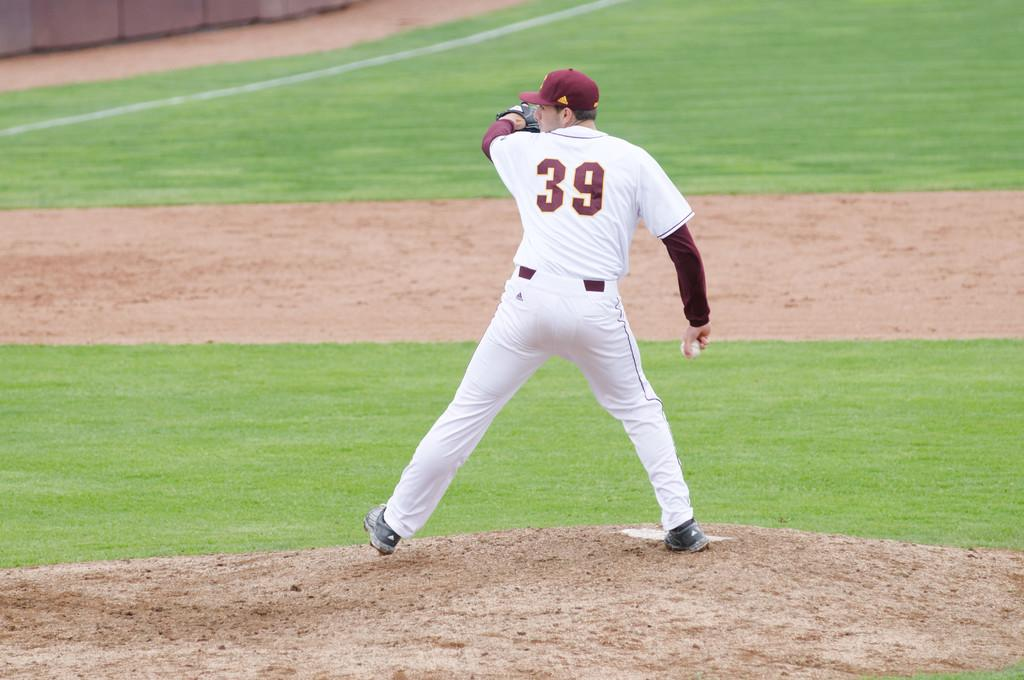<image>
Give a short and clear explanation of the subsequent image. a player that is wearing the number 39 on their back 